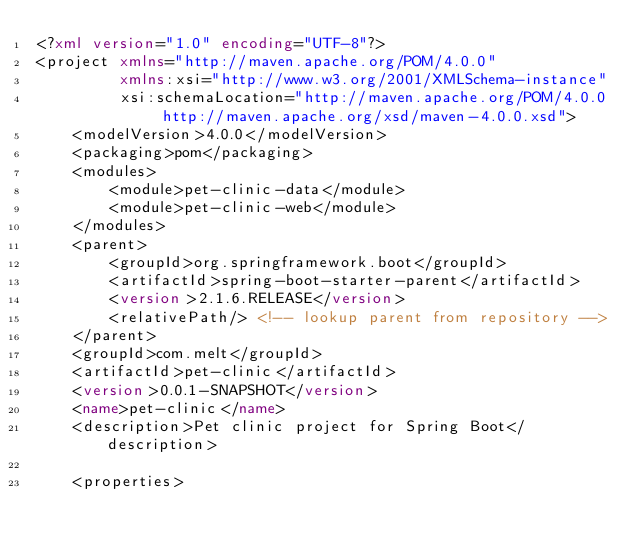Convert code to text. <code><loc_0><loc_0><loc_500><loc_500><_XML_><?xml version="1.0" encoding="UTF-8"?>
<project xmlns="http://maven.apache.org/POM/4.0.0"
         xmlns:xsi="http://www.w3.org/2001/XMLSchema-instance"
         xsi:schemaLocation="http://maven.apache.org/POM/4.0.0 http://maven.apache.org/xsd/maven-4.0.0.xsd">
    <modelVersion>4.0.0</modelVersion>
    <packaging>pom</packaging>
    <modules>
        <module>pet-clinic-data</module>
        <module>pet-clinic-web</module>
    </modules>
    <parent>
        <groupId>org.springframework.boot</groupId>
        <artifactId>spring-boot-starter-parent</artifactId>
        <version>2.1.6.RELEASE</version>
        <relativePath/> <!-- lookup parent from repository -->
    </parent>
    <groupId>com.melt</groupId>
    <artifactId>pet-clinic</artifactId>
    <version>0.0.1-SNAPSHOT</version>
    <name>pet-clinic</name>
    <description>Pet clinic project for Spring Boot</description>

    <properties></code> 